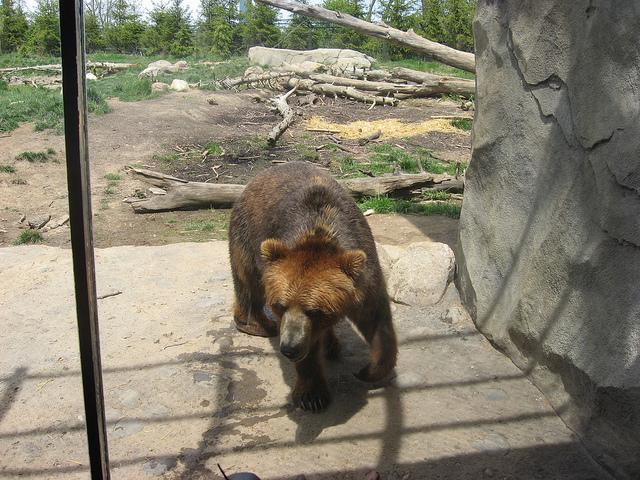Is the bear in his natural habitat?
Answer briefly. No. Do the tree logs have bark on them?
Quick response, please. No. Is the bear on the grass?
Be succinct. No. 